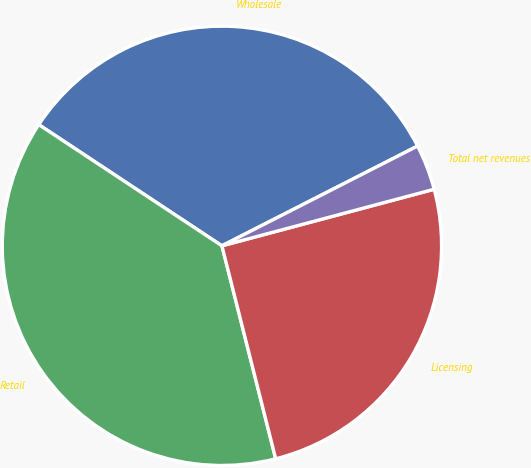<chart> <loc_0><loc_0><loc_500><loc_500><pie_chart><fcel>Wholesale<fcel>Retail<fcel>Licensing<fcel>Total net revenues<nl><fcel>33.19%<fcel>38.24%<fcel>25.21%<fcel>3.36%<nl></chart> 